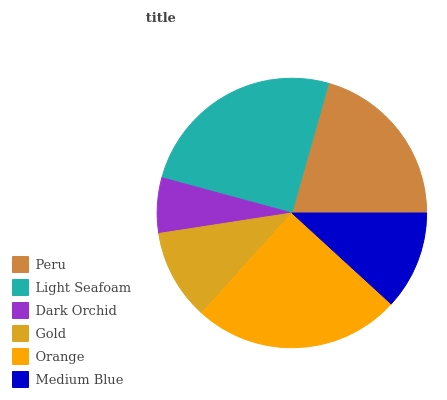Is Dark Orchid the minimum?
Answer yes or no. Yes. Is Light Seafoam the maximum?
Answer yes or no. Yes. Is Light Seafoam the minimum?
Answer yes or no. No. Is Dark Orchid the maximum?
Answer yes or no. No. Is Light Seafoam greater than Dark Orchid?
Answer yes or no. Yes. Is Dark Orchid less than Light Seafoam?
Answer yes or no. Yes. Is Dark Orchid greater than Light Seafoam?
Answer yes or no. No. Is Light Seafoam less than Dark Orchid?
Answer yes or no. No. Is Peru the high median?
Answer yes or no. Yes. Is Medium Blue the low median?
Answer yes or no. Yes. Is Orange the high median?
Answer yes or no. No. Is Light Seafoam the low median?
Answer yes or no. No. 